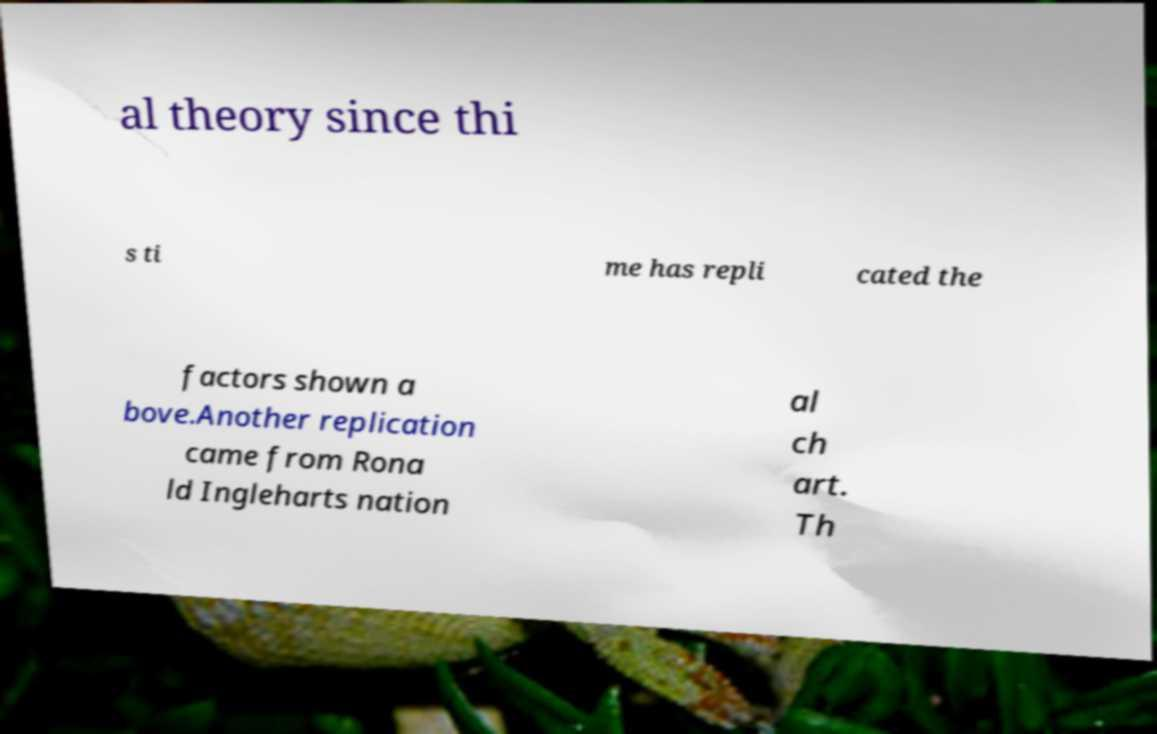Can you accurately transcribe the text from the provided image for me? al theory since thi s ti me has repli cated the factors shown a bove.Another replication came from Rona ld Ingleharts nation al ch art. Th 